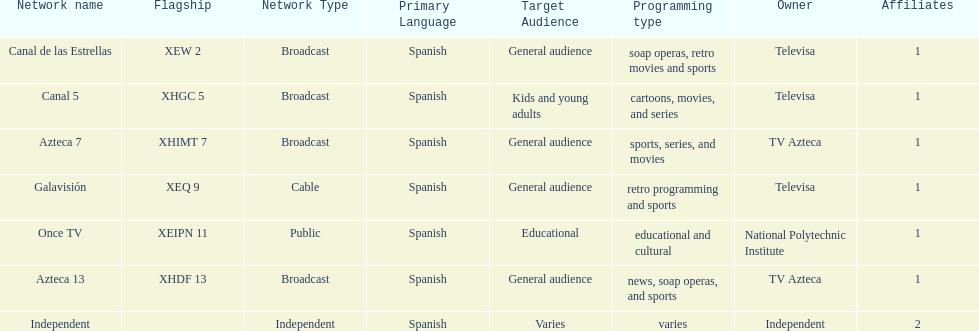What is the number of affiliates associated with galavision? 1. 